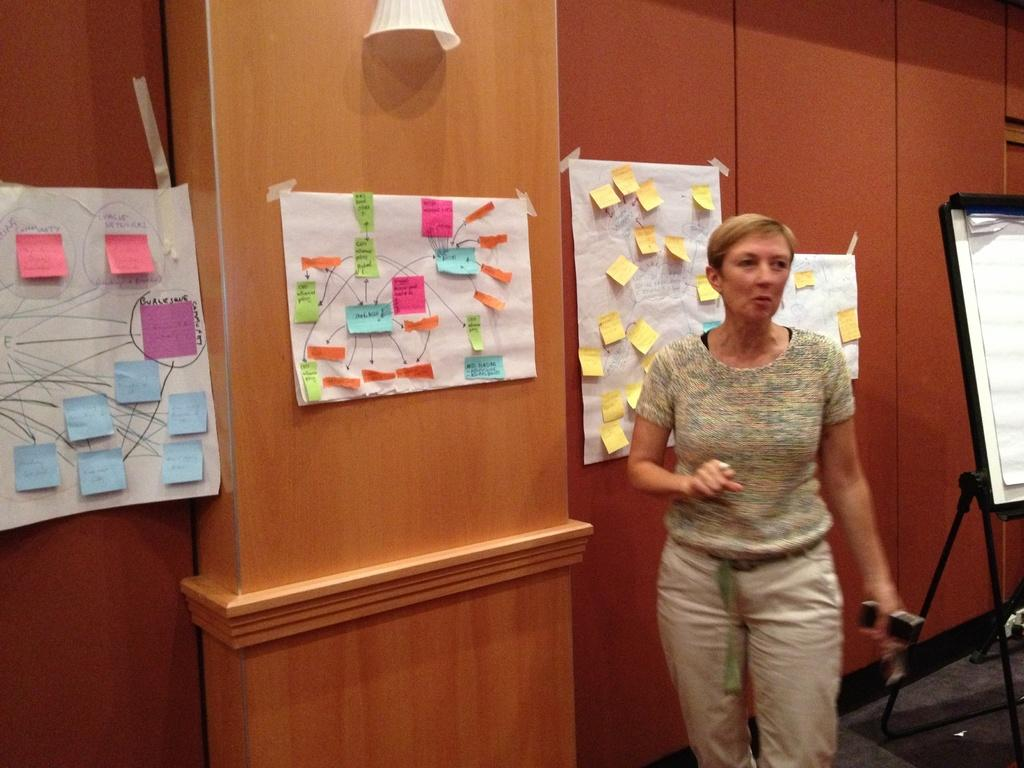What is the main subject of the image? There is a woman standing in the center of the image. What is the woman holding in the image? The woman is holding an object. What can be seen in the background of the image? There is a wall, a board, a stand, posters, and notes in the background of the image. What type of office furniture can be seen in the image? There is no office furniture present in the image. What suggestion does the woman provide in the image? The image does not show the woman providing any suggestions; it only shows her holding an object. 